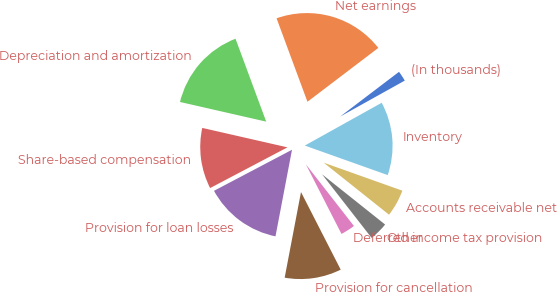Convert chart. <chart><loc_0><loc_0><loc_500><loc_500><pie_chart><fcel>(In thousands)<fcel>Net earnings<fcel>Depreciation and amortization<fcel>Share-based compensation<fcel>Provision for loan losses<fcel>Provision for cancellation<fcel>Deferred income tax provision<fcel>Other<fcel>Accounts receivable net<fcel>Inventory<nl><fcel>2.26%<fcel>20.3%<fcel>15.79%<fcel>11.28%<fcel>14.29%<fcel>10.53%<fcel>3.01%<fcel>3.76%<fcel>5.26%<fcel>13.53%<nl></chart> 